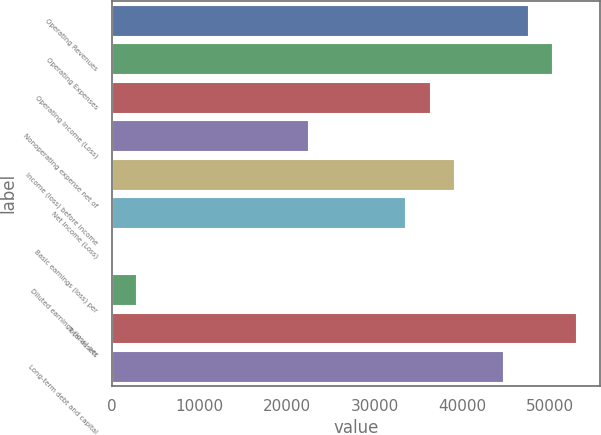Convert chart. <chart><loc_0><loc_0><loc_500><loc_500><bar_chart><fcel>Operating Revenues<fcel>Operating Expenses<fcel>Operating Income (Loss)<fcel>Nonoperating expense net of<fcel>Income (loss) before income<fcel>Net Income (Loss)<fcel>Basic earnings (loss) per<fcel>Diluted earnings (loss) per<fcel>Total assets<fcel>Long-term debt and capital<nl><fcel>47441.1<fcel>50231.5<fcel>36279.3<fcel>22327.2<fcel>39069.8<fcel>33488.9<fcel>3.74<fcel>2794.17<fcel>53021.9<fcel>44650.6<nl></chart> 